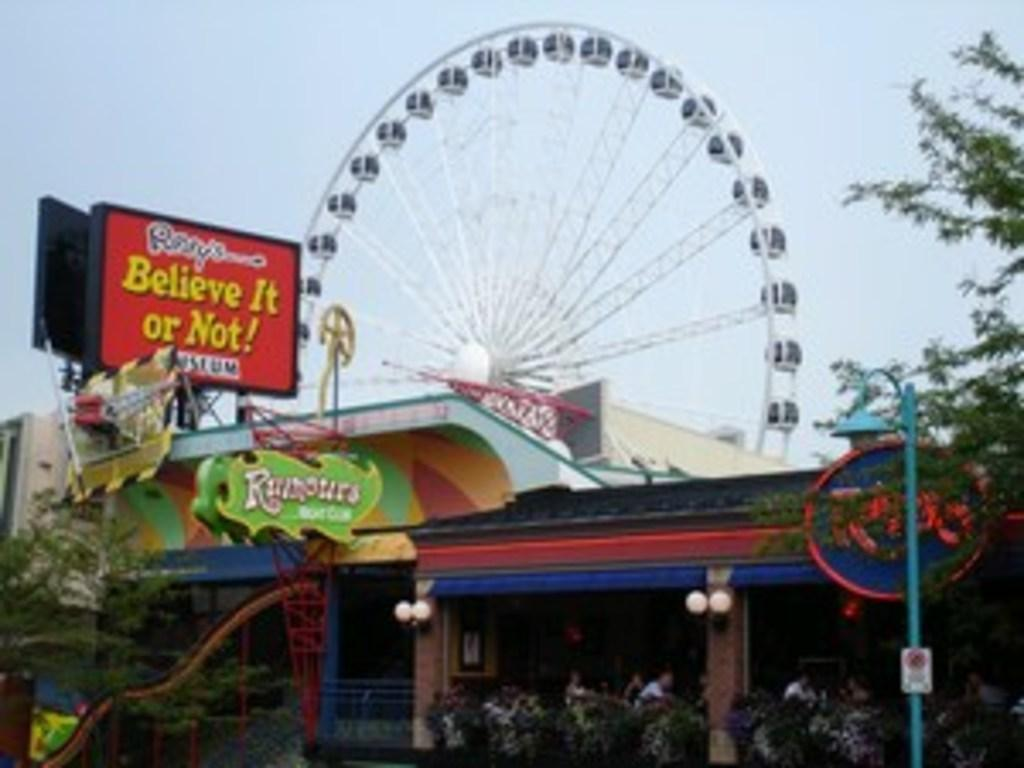What type of vegetation can be seen in the image? There are trees in the image. What type of advertising or signage is present in the image? There are hoardings in the image. What vertical structure can be seen in the image? There is a pole in the image. What type of residential structures are visible in the image? There are houses in the image. What type of amusement ride is present in the image? There is a giant wheel in the image. Can you tell me how many eggs are in the nest in the image? There is no nest or eggs present in the image. What is the rate of the giant wheel in the image? The image does not provide information about the rate of the giant wheel. 